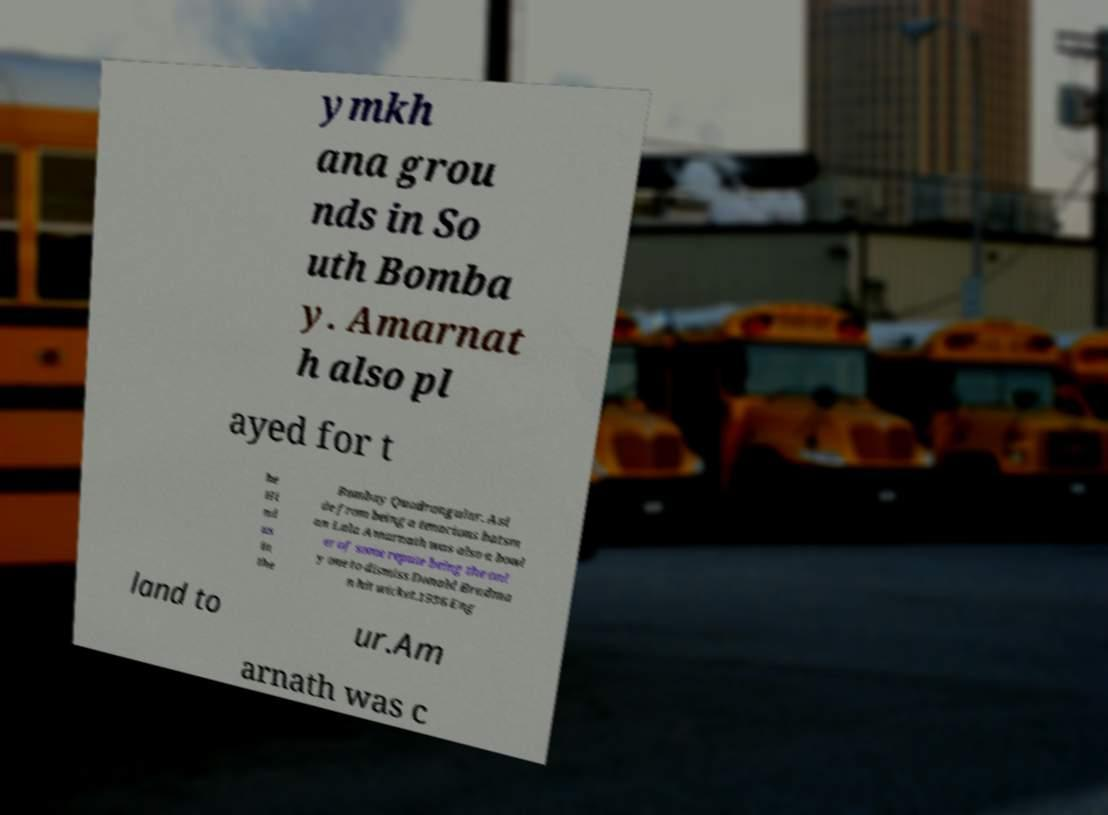I need the written content from this picture converted into text. Can you do that? ymkh ana grou nds in So uth Bomba y. Amarnat h also pl ayed for t he Hi nd us in the Bombay Quadrangular. Asi de from being a tenacious batsm an Lala Amarnath was also a bowl er of some repute being the onl y one to dismiss Donald Bradma n hit wicket.1936 Eng land to ur.Am arnath was c 